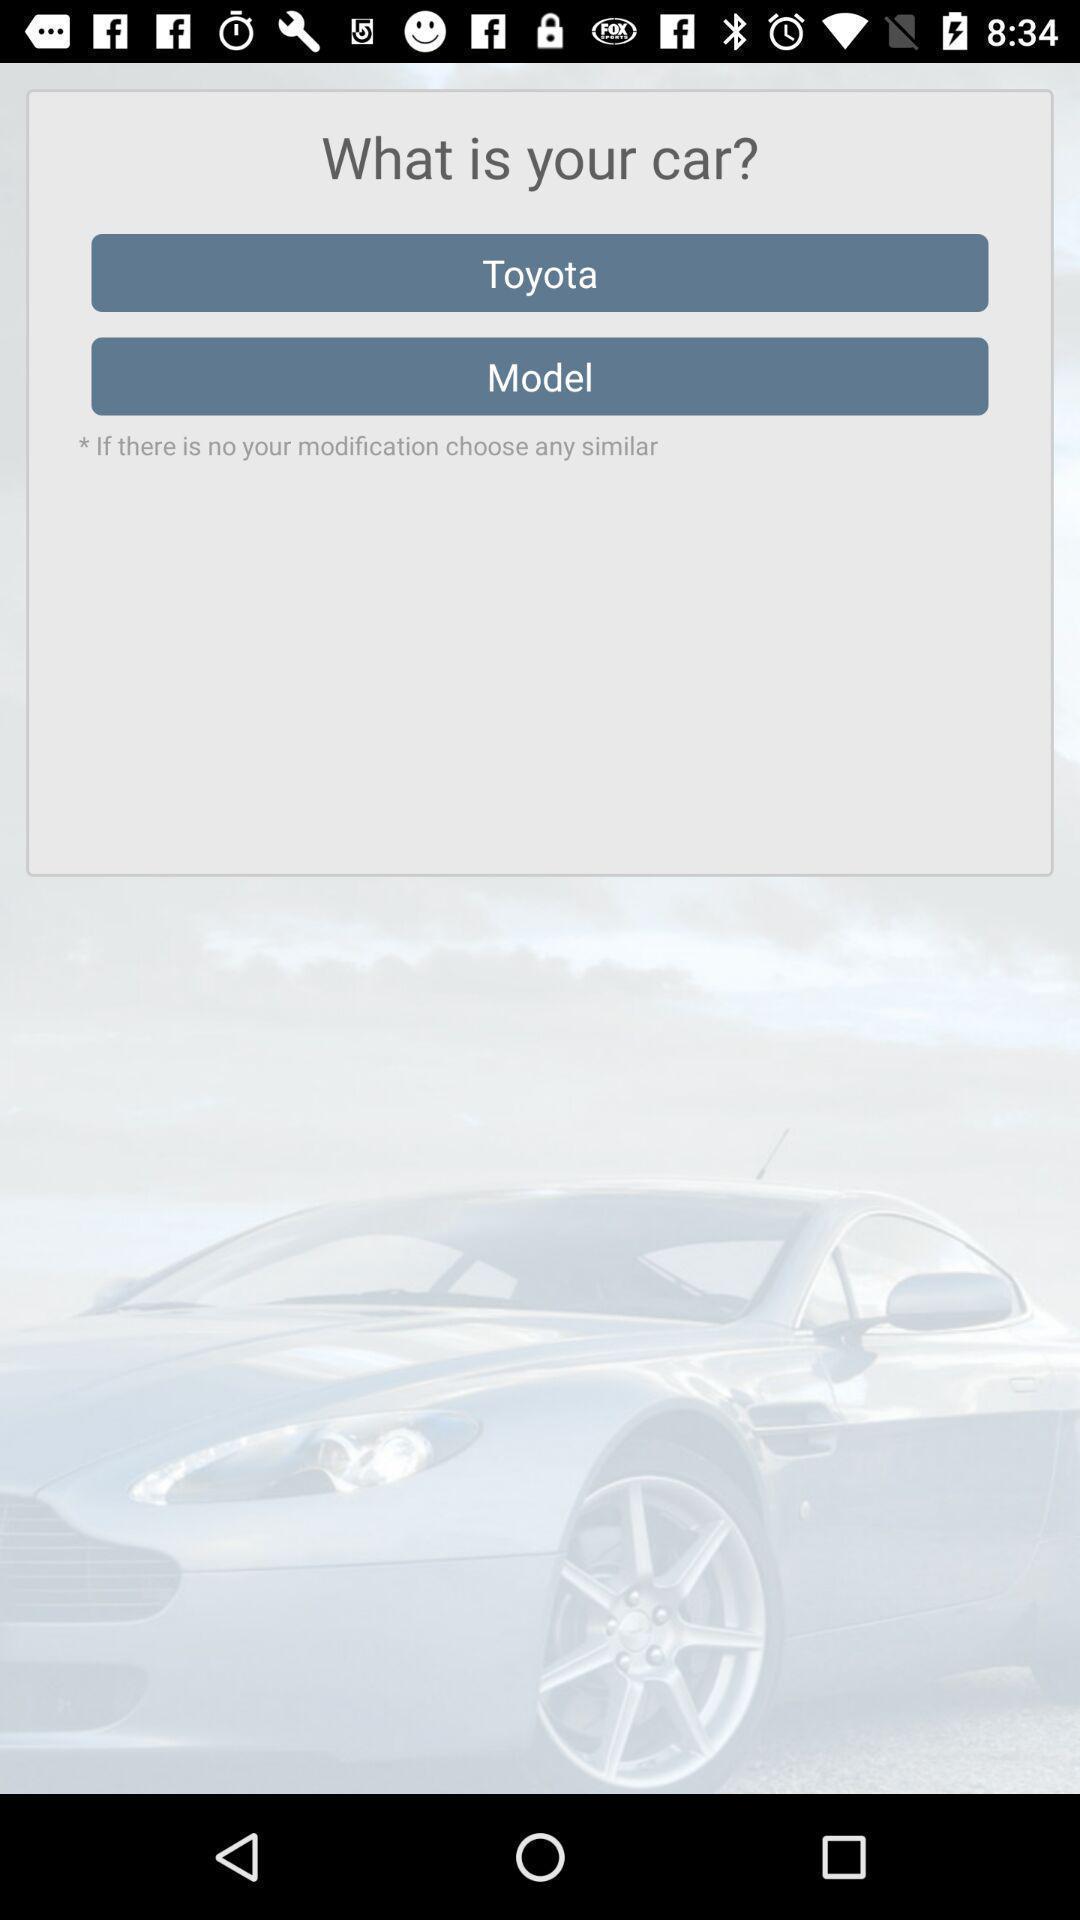Tell me about the visual elements in this screen capture. Pop up to select a car. 